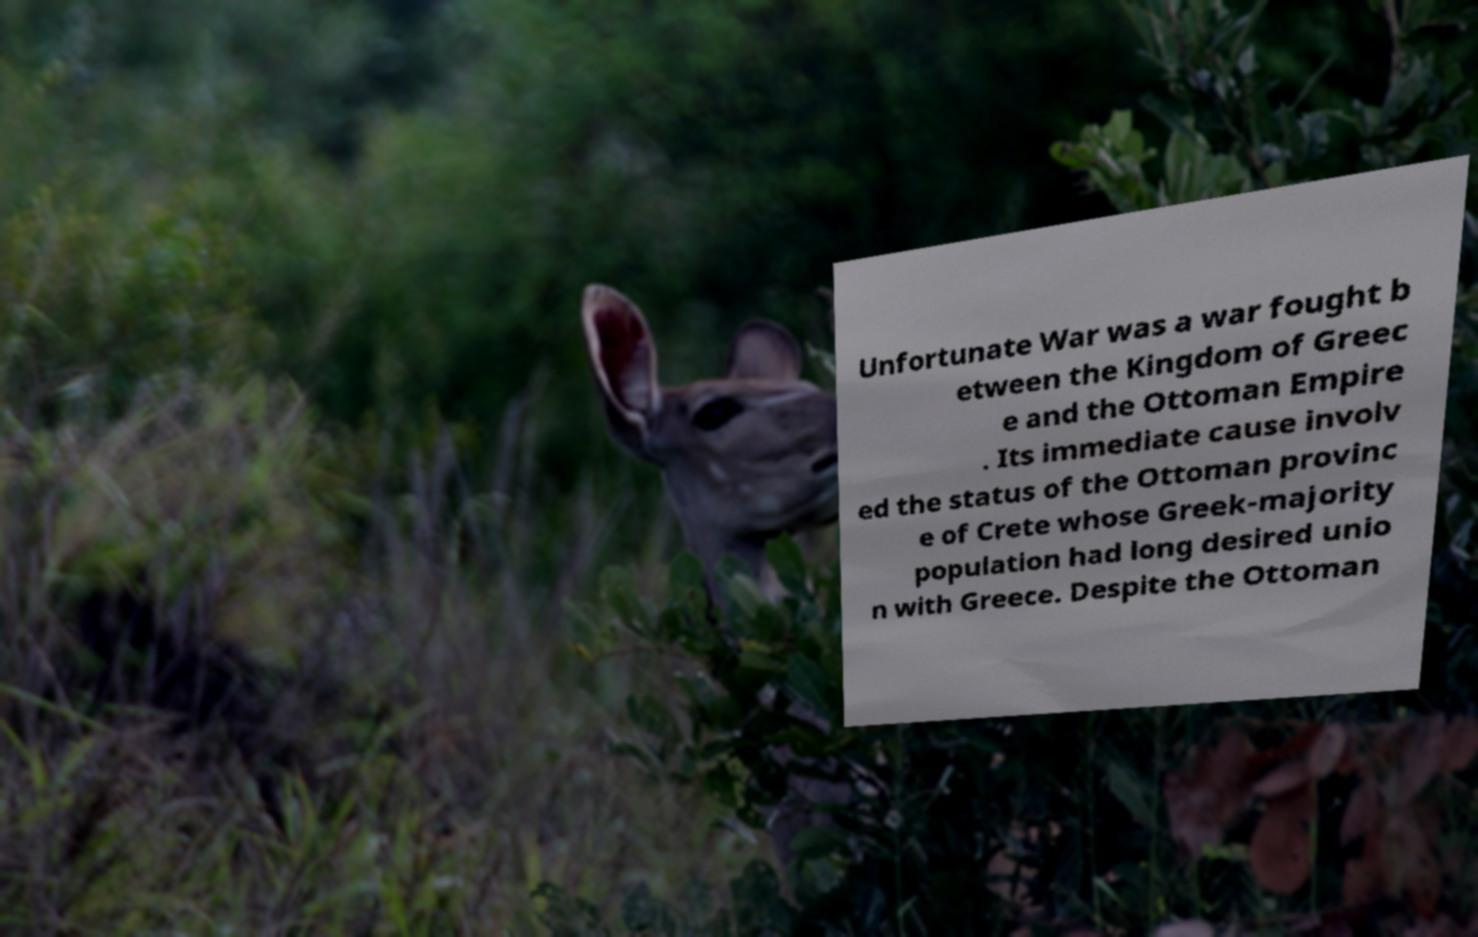Please read and relay the text visible in this image. What does it say? Unfortunate War was a war fought b etween the Kingdom of Greec e and the Ottoman Empire . Its immediate cause involv ed the status of the Ottoman provinc e of Crete whose Greek-majority population had long desired unio n with Greece. Despite the Ottoman 